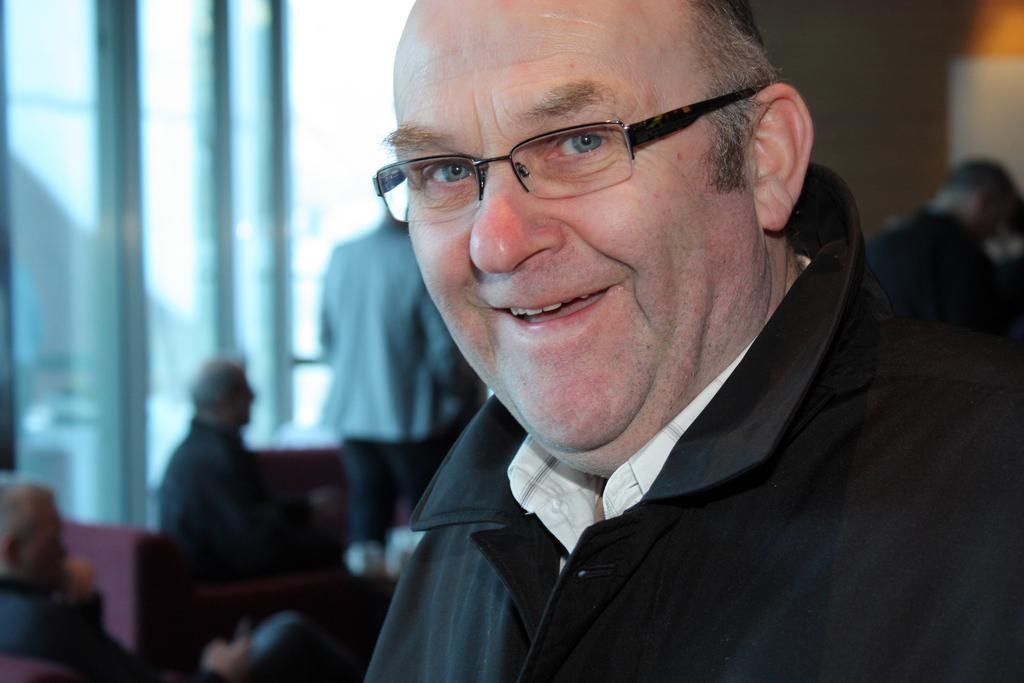How many poles can be seen in the image? There are three poles in the image. What else is present in the image besides the poles? There is a board, some people standing, a wall, and two people sitting on chairs in the image. What might the board be used for in the image? The board could be used for displaying information or as a surface for writing or drawing. How many people are sitting in the image? Two people are sitting on chairs in the image. What type of nut is being used as an apparatus in the image? There is no nut or apparatus present in the image. What is the earth like in the image? The image does not depict the earth or any geographical features; it is a scene with poles, a board, people, and a wall. 